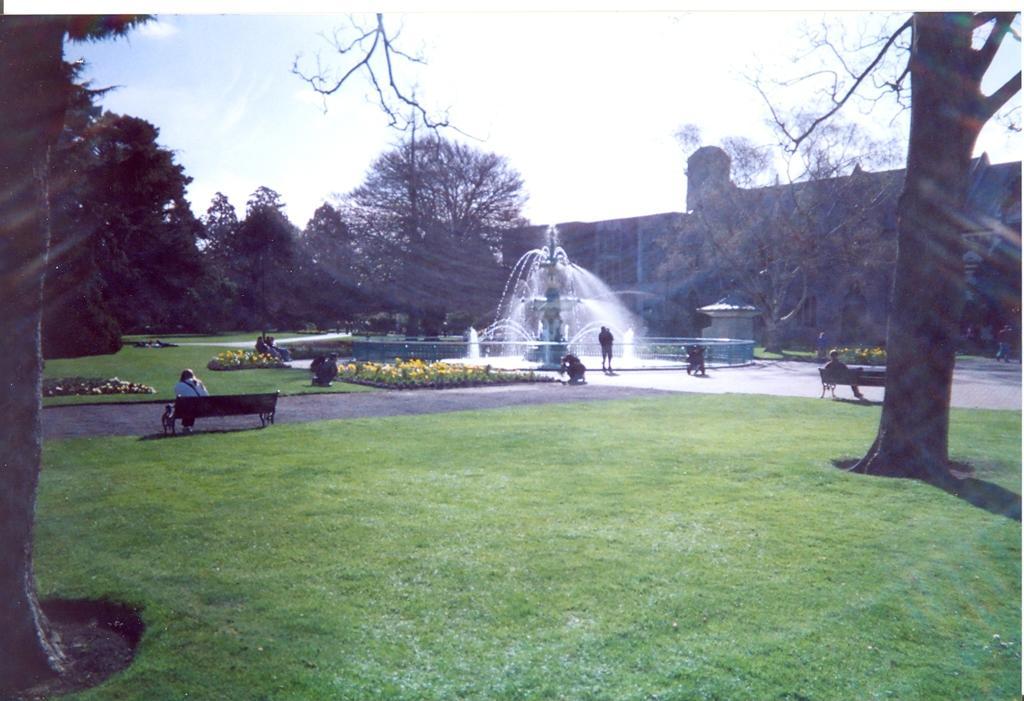Please provide a concise description of this image. In this image there is a person sitting on the bench which is on the path. Before him there are few plants on the grassland. Behind the plants few persons are sitting on the bench. Middle of image there is a fountain. Few persons are standing on the floor. Right side a person is sitting on the bench. Behind him there is a tree on the grassland. Background there are few trees. Behind it there is a building. Top of image there is sky. 